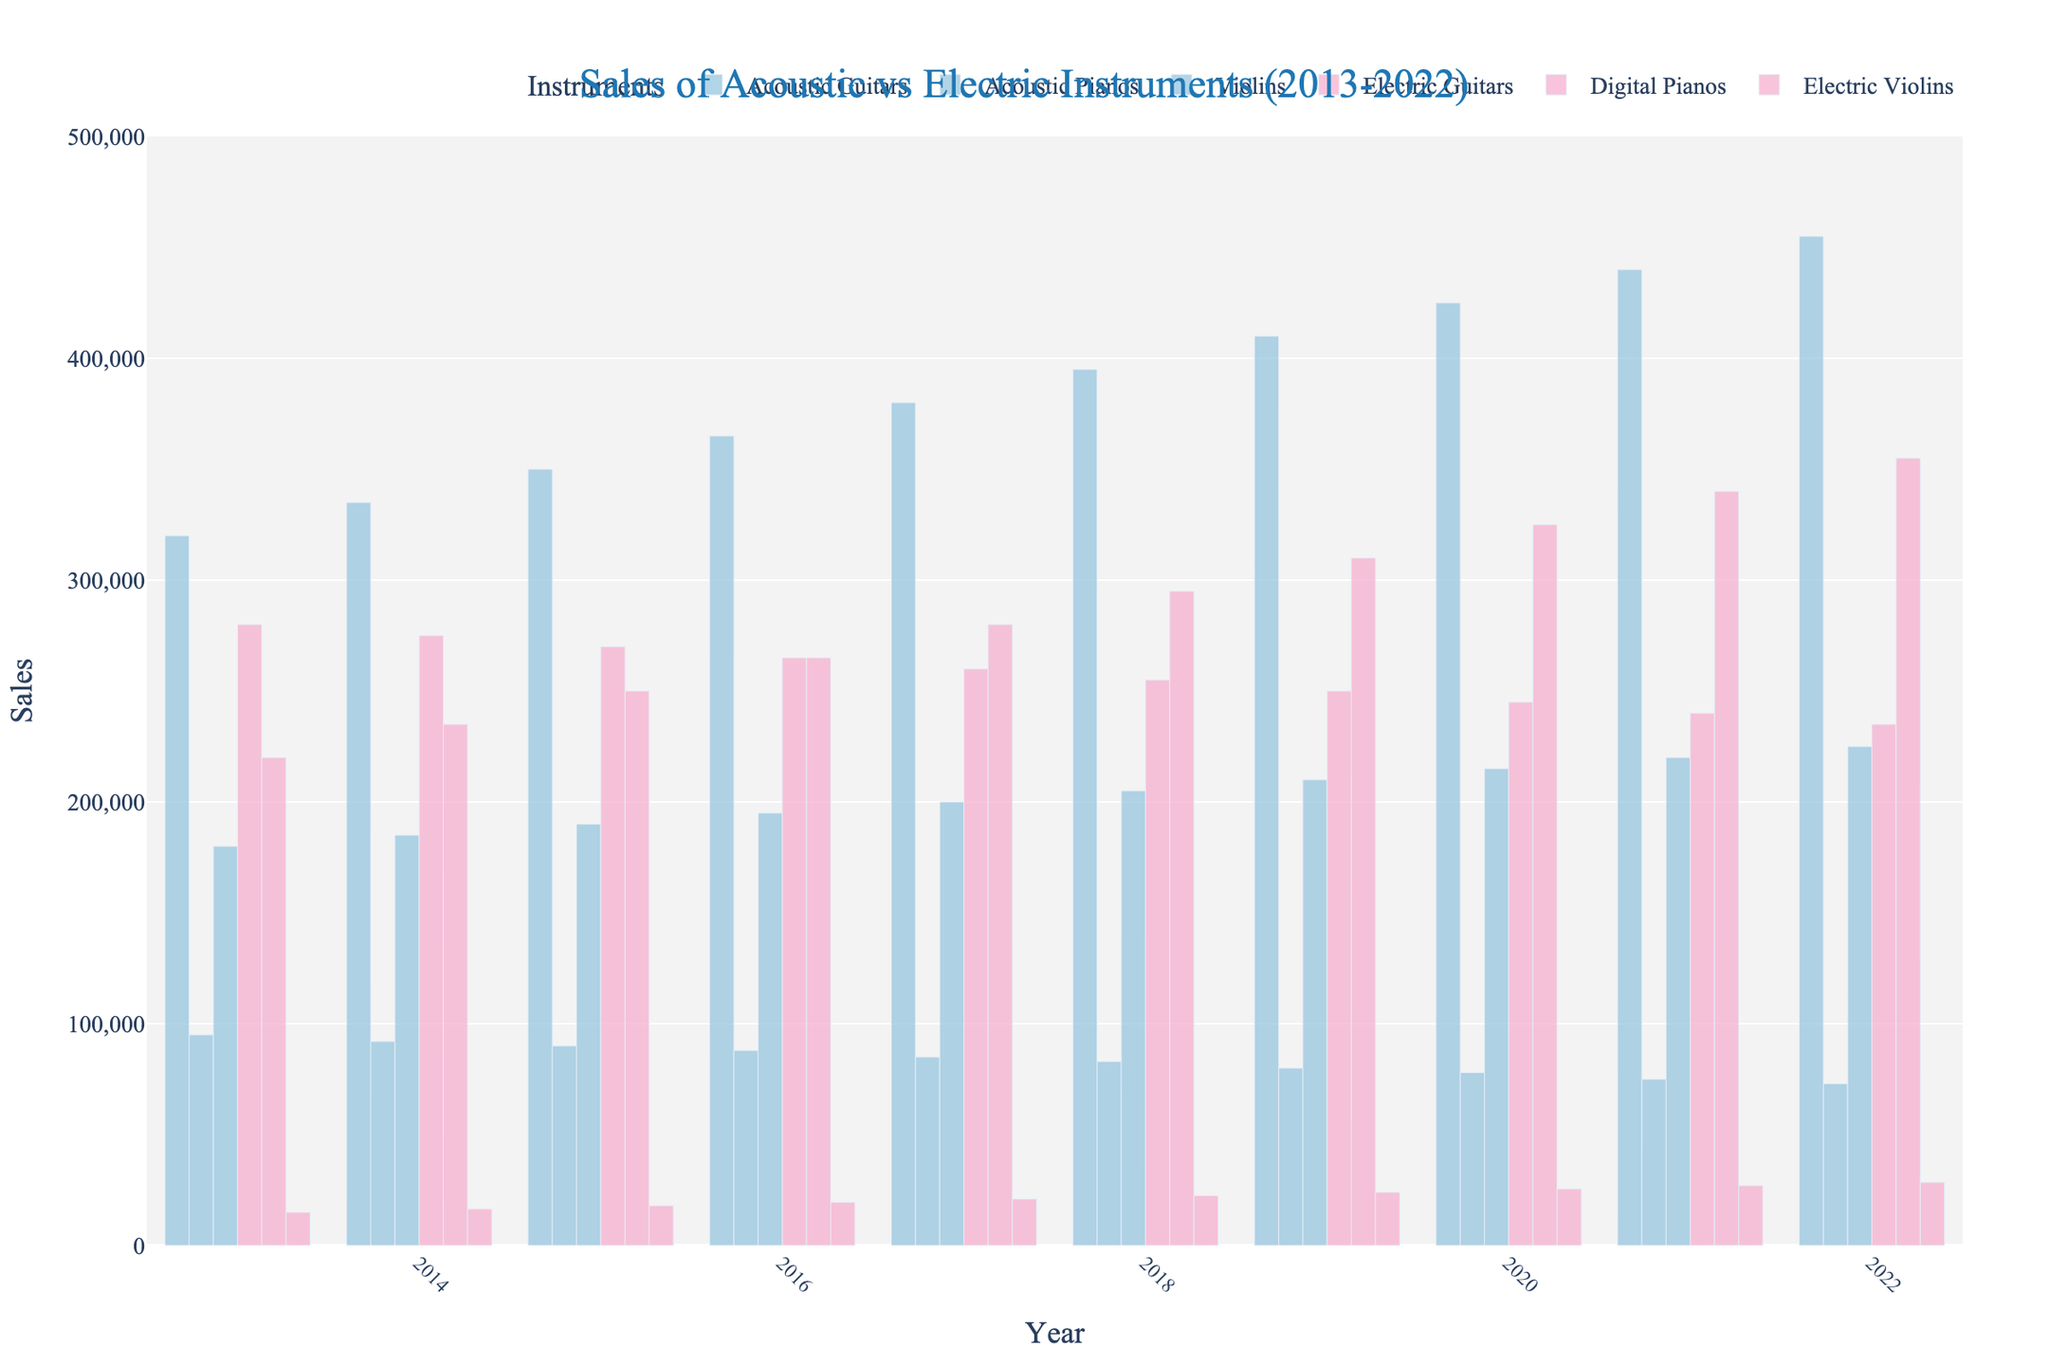Which year saw the highest sales of Acoustic Guitars? Looking at the bars representing the sales of Acoustic Guitars across the years, the highest bar corresponds to the year 2022.
Answer: 2022 How do the sales of Digital Pianos and Acoustic Pianos in 2017 compare? In 2017, the bar for Digital Pianos is higher than the bar for Acoustic Pianos, indicating that more Digital Pianos were sold.
Answer: Digital Pianos had higher sales What is the trend observed in sales of Electric Guitars over the decade? Observing the bars for Electric Guitars from 2013 to 2022, the height of the bars shows a slight decreasing trend, indicating a decrease in sales.
Answer: Decreasing trend What is the difference in sales between Electric Violins and Acoustic Violins in 2022? In 2022, the sales for Electric Violins are 28,500 and for Acoustic Violins are 225,000. Subtracting these gives us the difference: 225,000 - 28,500 = 196,500.
Answer: 196,500 Which type of instrument saw the greatest increase in sales from 2013 to 2022? Comparing the bars for all instruments from 2013 to 2022, the Acoustic Guitars saw an increase from 320,000 to 455,000. The increase is 455,000 - 320,000 = 135,000, which is larger than any other increment observed for other instruments.
Answer: Acoustic Guitars What are the total sales of all acoustic instruments in 2015? To find the total, add the sales of Acoustic Guitars (350,000), Acoustic Pianos (90,000), and Violins (190,000) in 2015: 350,000 + 90,000 + 190,000 = 630,000.
Answer: 630,000 Are the sales of Electric Violins higher in 2018 or Acoustic Pianos in 2018? Comparing the bars, the sales for Electric Violins in 2018 are 22,500 and for Acoustic Pianos are 83,000. So Acoustic Pianos have higher sales.
Answer: Acoustic Pianos How much did Digital Piano sales increase from 2013 to 2022? Digital Piano sales increased from 220,000 in 2013 to 355,000 in 2022. The increase is 355,000 - 220,000 = 135,000.
Answer: 135,000 What is the average annual sales figure for Violins from 2013 to 2022? Summing the sales figures for Violins from 2013 to 2022 and dividing by the number of years: (180,000 + 185,000 + 190,000 + 195,000 + 200,000 + 205,000 + 210,000 + 215,000 + 220,000 + 225,000) / 10 = 2,035,000 / 10 = 203,500.
Answer: 203,500 